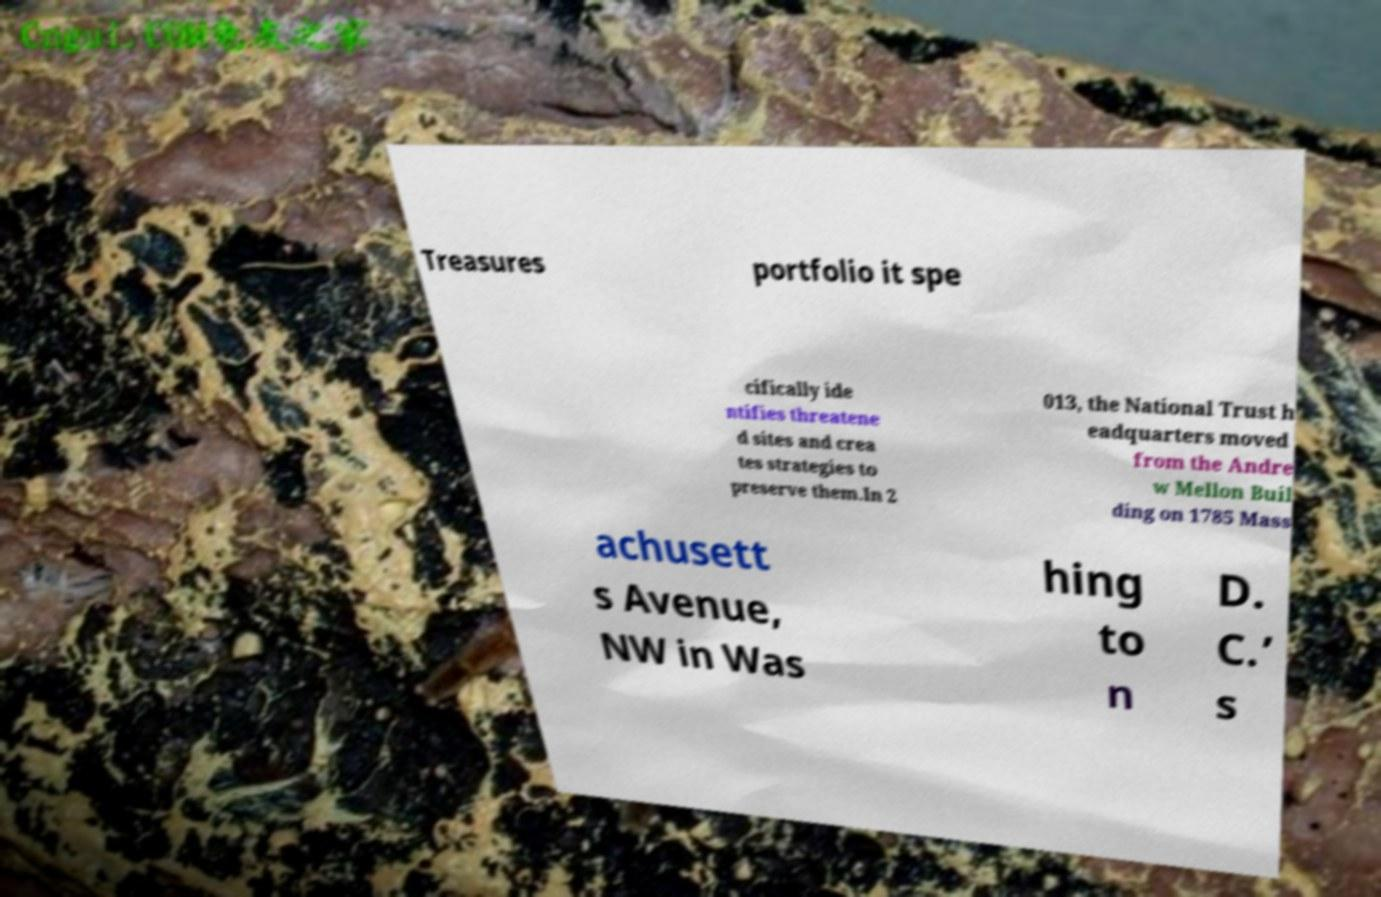There's text embedded in this image that I need extracted. Can you transcribe it verbatim? Treasures portfolio it spe cifically ide ntifies threatene d sites and crea tes strategies to preserve them.In 2 013, the National Trust h eadquarters moved from the Andre w Mellon Buil ding on 1785 Mass achusett s Avenue, NW in Was hing to n D. C.’ s 